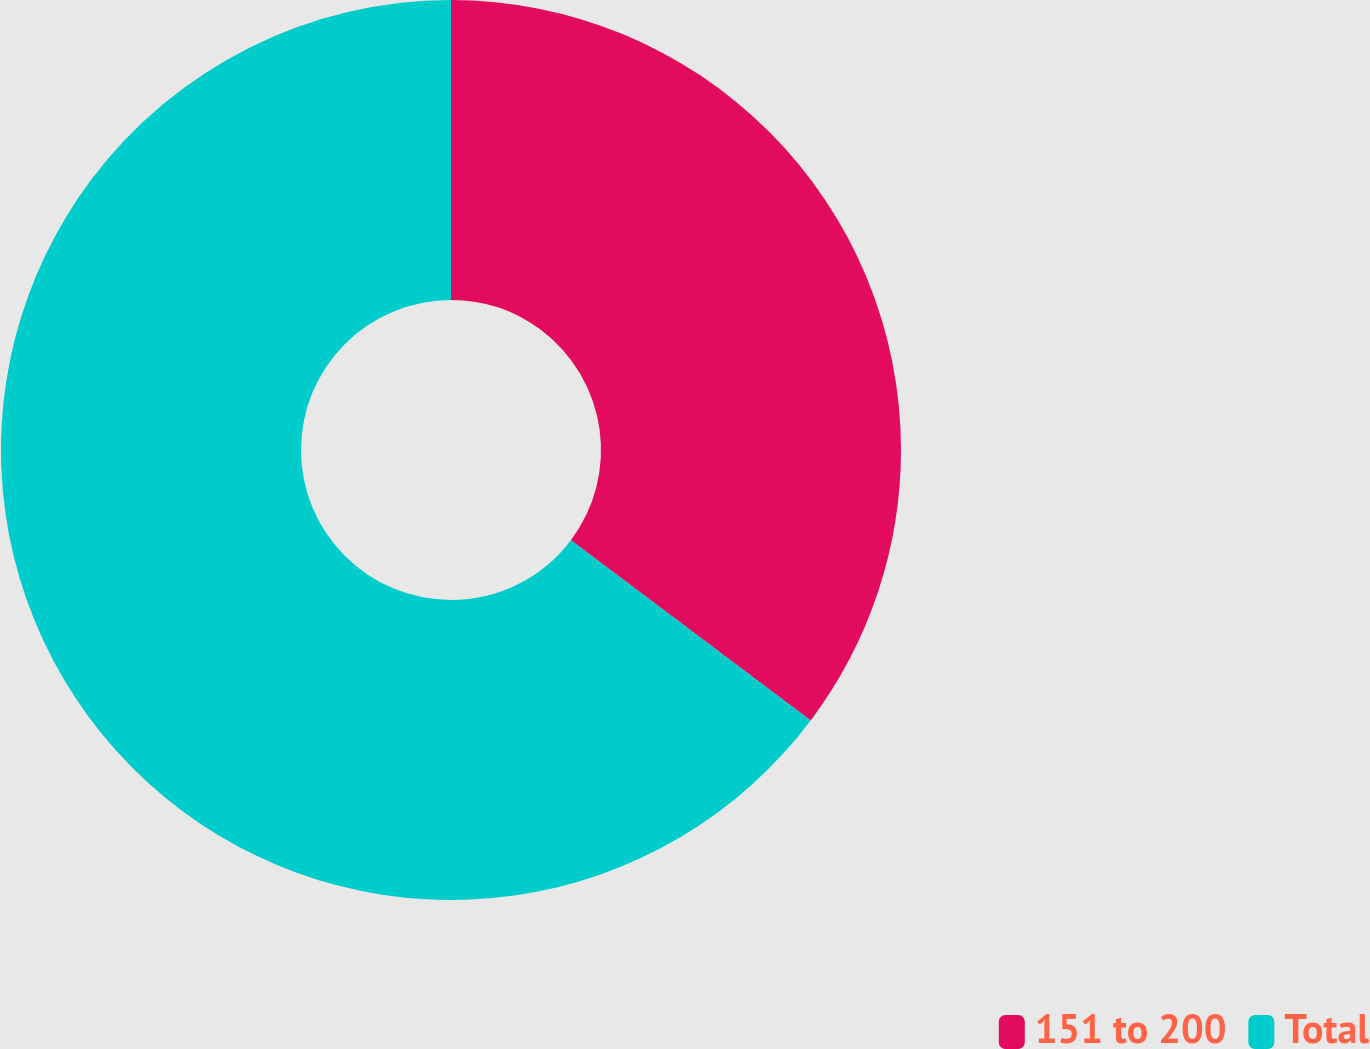<chart> <loc_0><loc_0><loc_500><loc_500><pie_chart><fcel>151 to 200<fcel>Total<nl><fcel>35.26%<fcel>64.74%<nl></chart> 